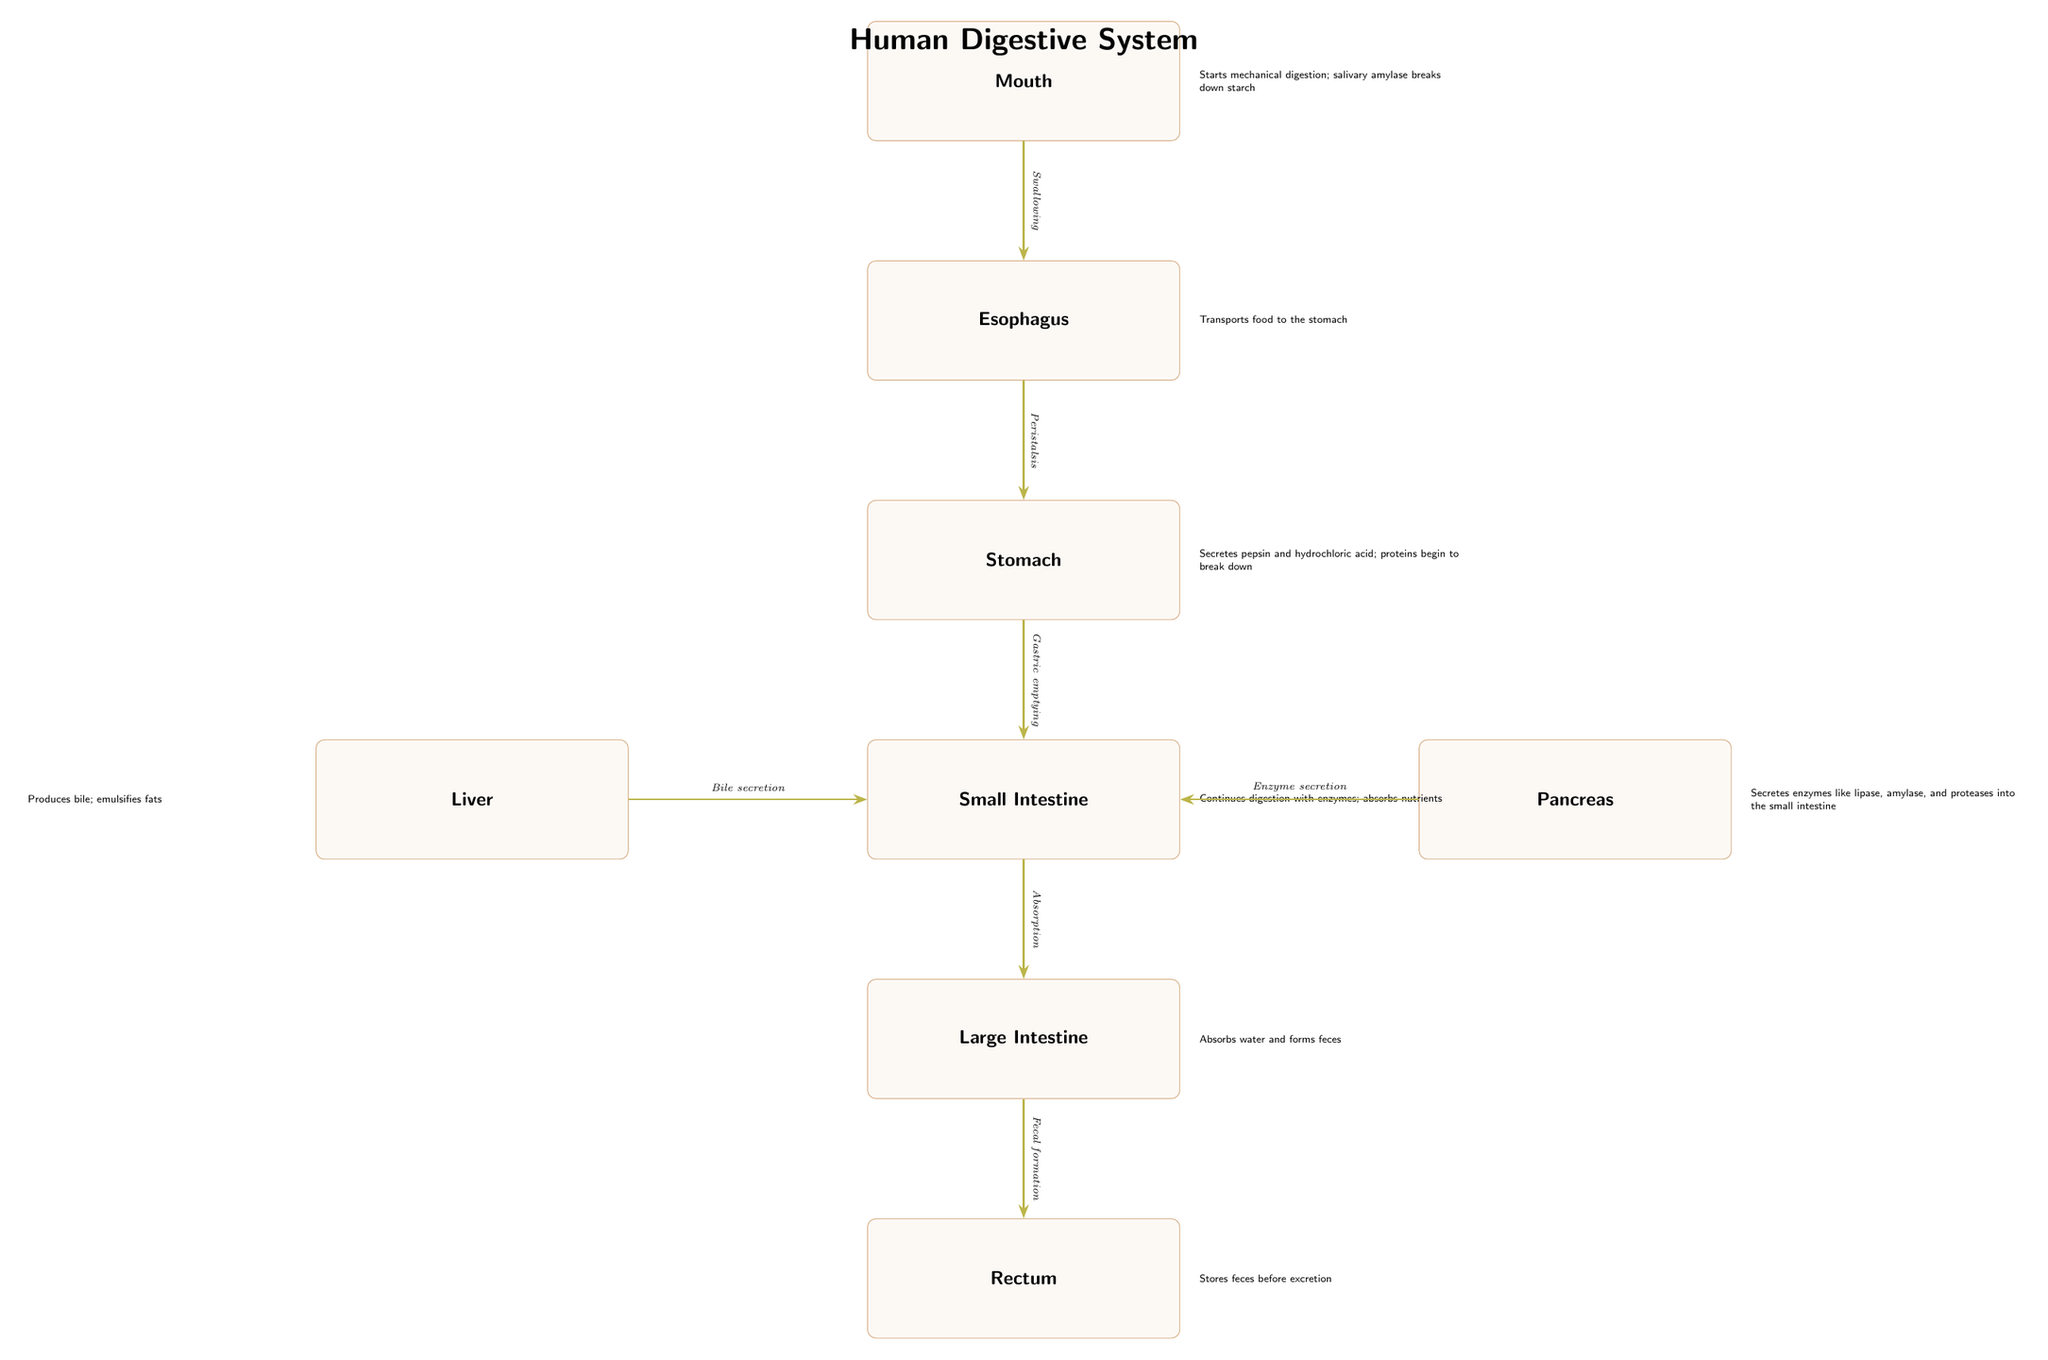What is the first organ involved in digestion? The diagram displays the flow of digestion starting from the mouth as the first organ involved, marked at the top.
Answer: Mouth What secretion occurs in the stomach? The stomach is described in the diagram as secreting pepsin and hydrochloric acid, indicating its role in protein breakdown.
Answer: Pepsin and hydrochloric acid Which organ produces bile? According to the diagram, the liver is indicated to produce bile, which is crucial for fat emulsification.
Answer: Liver How does food move from the esophagus to the stomach? The diagram illustrates the process of swallowing as the action that moves food from the esophagus to the stomach.
Answer: Swallowing What nutrient absorption occurs primarily in the small intestine? The small intestine is indicated in the diagram to continue digestion and absorb nutrients, making it the key site for nutrient absorption in the digestive system.
Answer: Nutrients What is the role of the pancreas in digestion? The diagram shows that the pancreas secretes enzymes like lipase, amylase, and proteases into the small intestine, indicating its vital role in enzymatic digestion.
Answer: Enzyme secretion How is water absorbed in the large intestine? The large intestine's function, as depicted in the diagram, focuses on water absorption and feces formation, signifying its critical role in hydration and waste management.
Answer: Absorbs water What sequence follows the stomach in the digestive process? As per the diagram, gastric emptying follows the stomach, leading to the small intestine, showing the smooth transition in the digestive pathway.
Answer: Small Intestine What connects the liver and small intestine? The diagram details that bile secretion is the process that connects the liver directly to the small intestine, highlighting the digestive link between them.
Answer: Bile secretion 